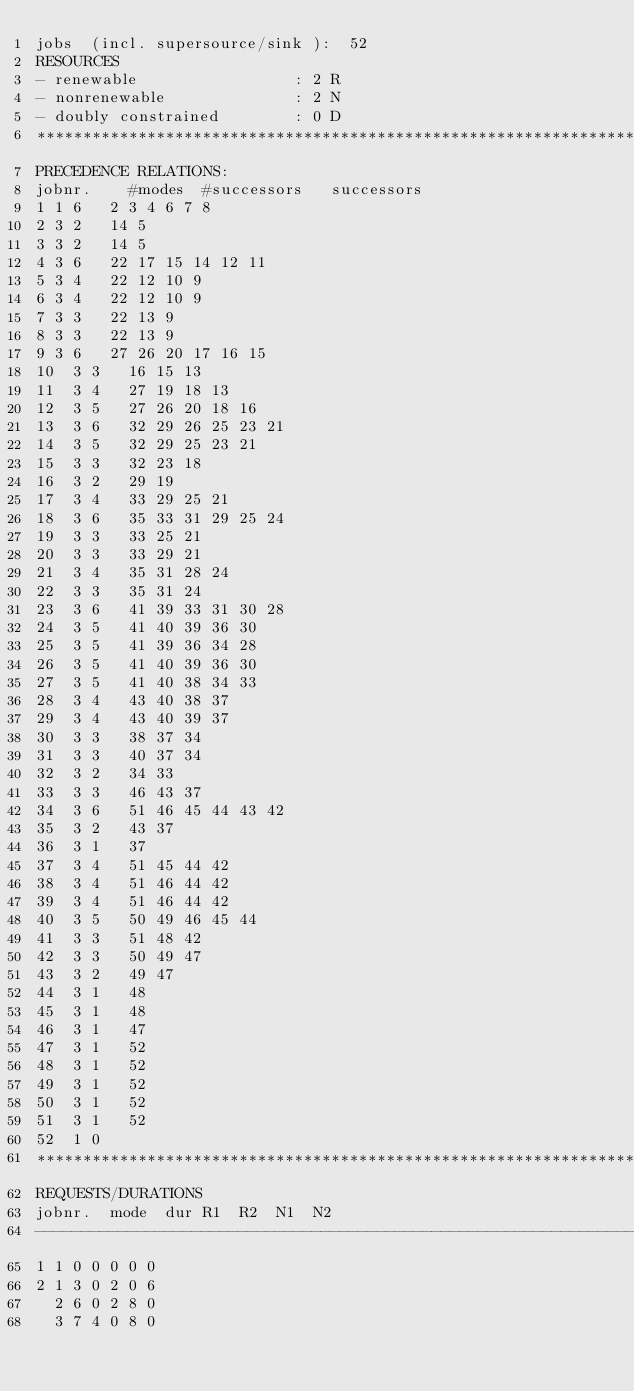<code> <loc_0><loc_0><loc_500><loc_500><_ObjectiveC_>jobs  (incl. supersource/sink ):	52
RESOURCES
- renewable                 : 2 R
- nonrenewable              : 2 N
- doubly constrained        : 0 D
************************************************************************
PRECEDENCE RELATIONS:
jobnr.    #modes  #successors   successors
1	1	6		2 3 4 6 7 8 
2	3	2		14 5 
3	3	2		14 5 
4	3	6		22 17 15 14 12 11 
5	3	4		22 12 10 9 
6	3	4		22 12 10 9 
7	3	3		22 13 9 
8	3	3		22 13 9 
9	3	6		27 26 20 17 16 15 
10	3	3		16 15 13 
11	3	4		27 19 18 13 
12	3	5		27 26 20 18 16 
13	3	6		32 29 26 25 23 21 
14	3	5		32 29 25 23 21 
15	3	3		32 23 18 
16	3	2		29 19 
17	3	4		33 29 25 21 
18	3	6		35 33 31 29 25 24 
19	3	3		33 25 21 
20	3	3		33 29 21 
21	3	4		35 31 28 24 
22	3	3		35 31 24 
23	3	6		41 39 33 31 30 28 
24	3	5		41 40 39 36 30 
25	3	5		41 39 36 34 28 
26	3	5		41 40 39 36 30 
27	3	5		41 40 38 34 33 
28	3	4		43 40 38 37 
29	3	4		43 40 39 37 
30	3	3		38 37 34 
31	3	3		40 37 34 
32	3	2		34 33 
33	3	3		46 43 37 
34	3	6		51 46 45 44 43 42 
35	3	2		43 37 
36	3	1		37 
37	3	4		51 45 44 42 
38	3	4		51 46 44 42 
39	3	4		51 46 44 42 
40	3	5		50 49 46 45 44 
41	3	3		51 48 42 
42	3	3		50 49 47 
43	3	2		49 47 
44	3	1		48 
45	3	1		48 
46	3	1		47 
47	3	1		52 
48	3	1		52 
49	3	1		52 
50	3	1		52 
51	3	1		52 
52	1	0		
************************************************************************
REQUESTS/DURATIONS
jobnr.	mode	dur	R1	R2	N1	N2	
------------------------------------------------------------------------
1	1	0	0	0	0	0	
2	1	3	0	2	0	6	
	2	6	0	2	8	0	
	3	7	4	0	8	0	</code> 